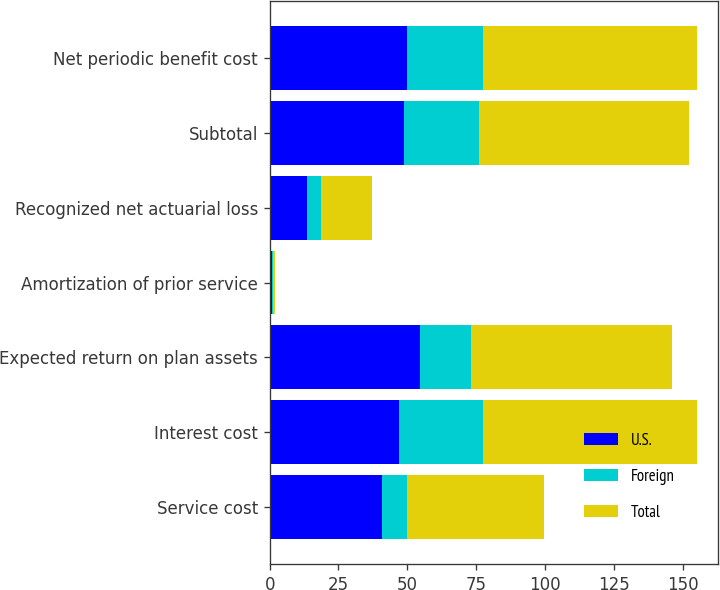Convert chart to OTSL. <chart><loc_0><loc_0><loc_500><loc_500><stacked_bar_chart><ecel><fcel>Service cost<fcel>Interest cost<fcel>Expected return on plan assets<fcel>Amortization of prior service<fcel>Recognized net actuarial loss<fcel>Subtotal<fcel>Net periodic benefit cost<nl><fcel>U.S.<fcel>40.9<fcel>47.1<fcel>54.5<fcel>0.9<fcel>13.5<fcel>48.7<fcel>50<nl><fcel>Foreign<fcel>8.9<fcel>30.5<fcel>18.5<fcel>0.5<fcel>5<fcel>27.5<fcel>27.6<nl><fcel>Total<fcel>49.8<fcel>77.6<fcel>73<fcel>0.4<fcel>18.5<fcel>76.2<fcel>77.6<nl></chart> 